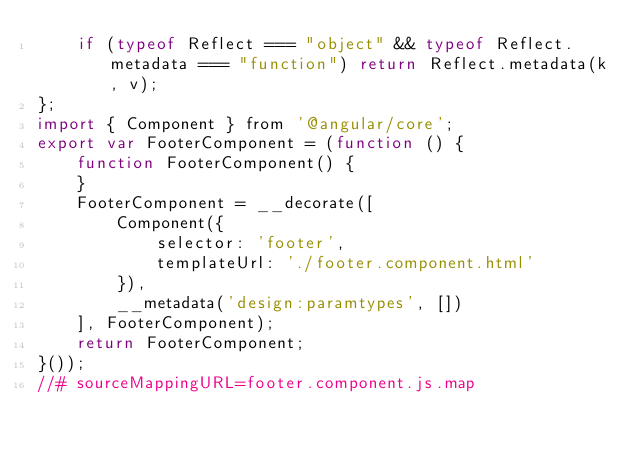Convert code to text. <code><loc_0><loc_0><loc_500><loc_500><_JavaScript_>    if (typeof Reflect === "object" && typeof Reflect.metadata === "function") return Reflect.metadata(k, v);
};
import { Component } from '@angular/core';
export var FooterComponent = (function () {
    function FooterComponent() {
    }
    FooterComponent = __decorate([
        Component({
            selector: 'footer',
            templateUrl: './footer.component.html'
        }), 
        __metadata('design:paramtypes', [])
    ], FooterComponent);
    return FooterComponent;
}());
//# sourceMappingURL=footer.component.js.map</code> 